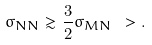Convert formula to latex. <formula><loc_0><loc_0><loc_500><loc_500>\sigma _ { N N } \gtrsim \frac { 3 } { 2 } \sigma _ { M N } \ > .</formula> 